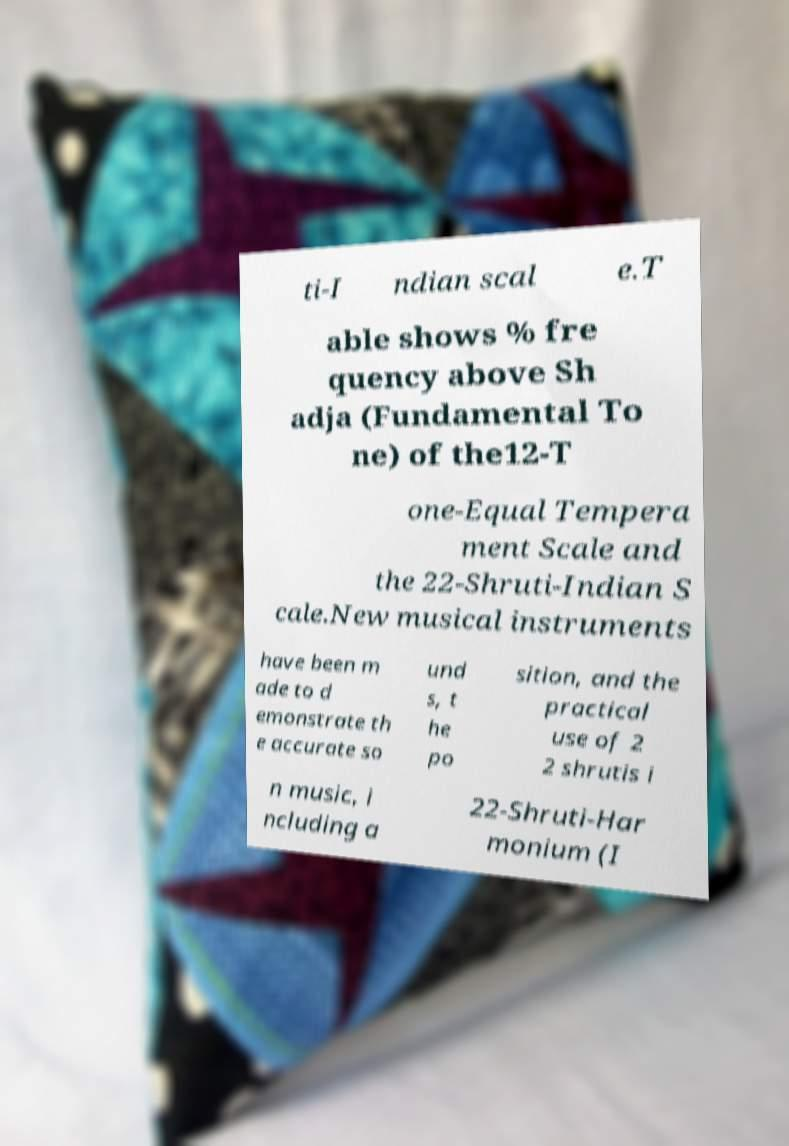Please read and relay the text visible in this image. What does it say? ti-I ndian scal e.T able shows % fre quency above Sh adja (Fundamental To ne) of the12-T one-Equal Tempera ment Scale and the 22-Shruti-Indian S cale.New musical instruments have been m ade to d emonstrate th e accurate so und s, t he po sition, and the practical use of 2 2 shrutis i n music, i ncluding a 22-Shruti-Har monium (I 